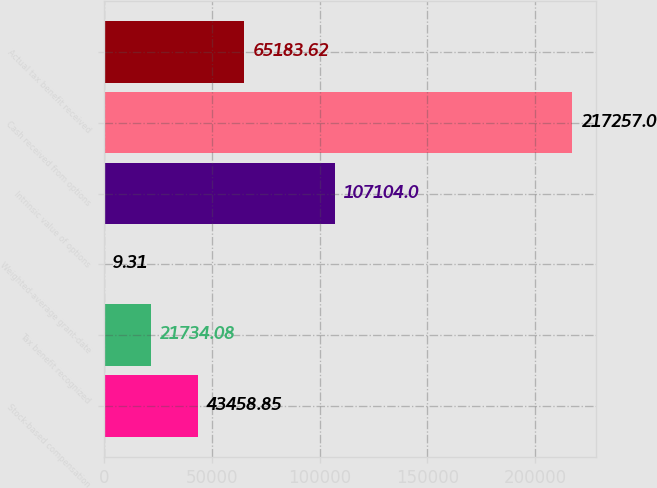Convert chart to OTSL. <chart><loc_0><loc_0><loc_500><loc_500><bar_chart><fcel>Stock-based compensation<fcel>Tax benefit recognized<fcel>Weighted-average grant-date<fcel>Intrinsic value of options<fcel>Cash received from options<fcel>Actual tax benefit received<nl><fcel>43458.8<fcel>21734.1<fcel>9.31<fcel>107104<fcel>217257<fcel>65183.6<nl></chart> 